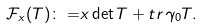<formula> <loc_0><loc_0><loc_500><loc_500>\mathcal { F } _ { x } ( T ) \colon = & x \det T + t r \, \gamma _ { 0 } T .</formula> 